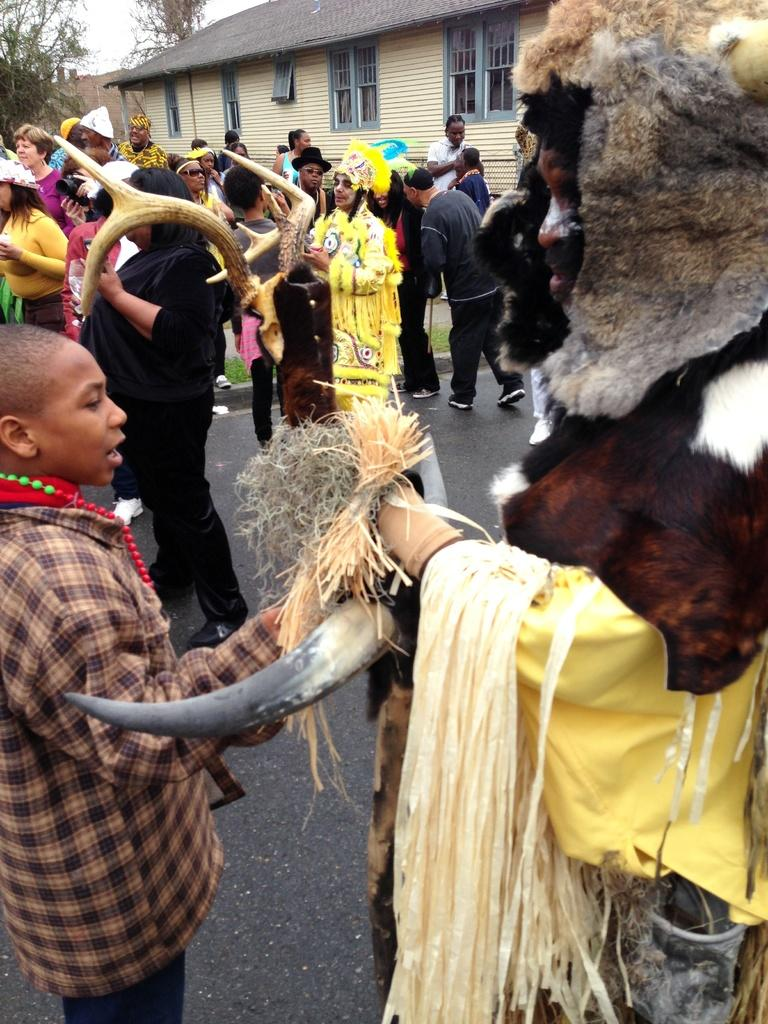What is happening on the road in the image? There are many people on the road in the image. What are some people doing in the image? Some people are wearing masks, and some are holding horns. What can be seen in the background of the image? There is a building and trees in the background of the image. What type of owl can be seen perched on the building in the image? There is no owl present in the image; it only features people on the road and a building in the background. What organization is responsible for the event taking place in the image? There is no indication of an event or organization in the image; it simply shows people on the road and a building in the background. 